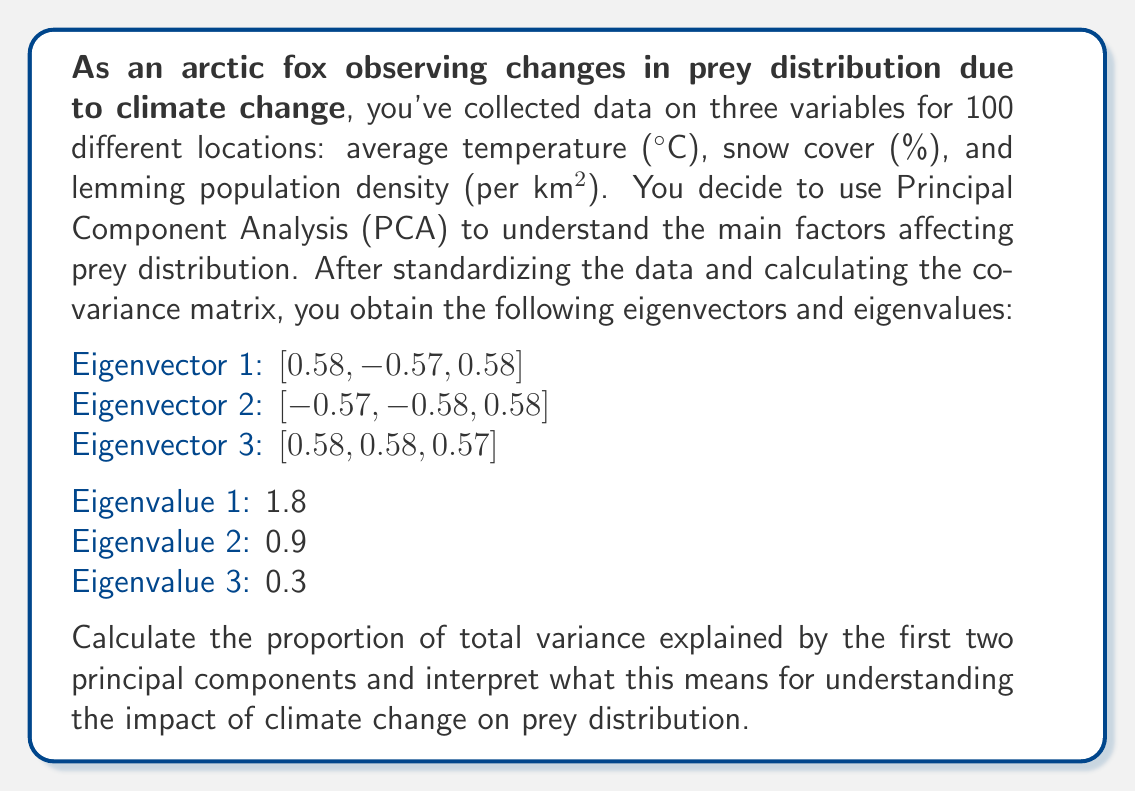Give your solution to this math problem. To solve this problem, we'll follow these steps:

1. Calculate the total variance
2. Calculate the proportion of variance explained by each component
3. Sum the proportions for the first two components
4. Interpret the results

Step 1: Calculate the total variance
The total variance is the sum of all eigenvalues:

$$ \text{Total Variance} = \sum_{i=1}^{3} \lambda_i = 1.8 + 0.9 + 0.3 = 3 $$

Step 2: Calculate the proportion of variance explained by each component
The proportion of variance explained by each component is its eigenvalue divided by the total variance:

For PC1: $\frac{1.8}{3} = 0.6$ or 60%
For PC2: $\frac{0.9}{3} = 0.3$ or 30%
For PC3: $\frac{0.3}{3} = 0.1$ or 10%

Step 3: Sum the proportions for the first two components
$$ \text{Proportion explained by PC1 and PC2} = 0.6 + 0.3 = 0.9 \text{ or } 90\% $$

Step 4: Interpret the results
The first two principal components explain 90% of the total variance in the data. This means that these two components capture the majority of the information about how temperature, snow cover, and lemming population density vary across the 100 locations.

In the context of climate change and prey distribution:

1. PC1 explains 60% of the variance, suggesting it's the most important factor. Given the eigenvector [0.58, -0.57, 0.58], this component likely represents a contrast between temperature and lemming density (positive) versus snow cover (negative).

2. PC2 explains an additional 30% of the variance. Its eigenvector [-0.57, -0.58, 0.58] suggests a contrast between lemming density and the other two variables.

3. Together, these two components provide a strong summary of how climate variables (temperature and snow cover) relate to prey distribution (lemming density).

4. The high proportion of variance explained (90%) indicates that these two components are sufficient to describe most of the variation in the data, allowing for a simplified analysis of how climate change impacts prey distribution.

5. As an arctic fox, this analysis helps you understand how changes in temperature and snow cover are likely to affect lemming populations, which is crucial for adapting your hunting strategies to the changing Arctic environment.
Answer: The proportion of total variance explained by the first two principal components is 0.9 or 90%. This high percentage indicates that these two components capture most of the variation in the data, providing a strong basis for understanding how climate variables (temperature and snow cover) relate to prey distribution (lemming density) in the context of climate change. 